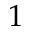<formula> <loc_0><loc_0><loc_500><loc_500>1</formula> 